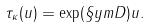Convert formula to latex. <formula><loc_0><loc_0><loc_500><loc_500>\tau _ { \kappa } ( u ) = \exp ( \S y m D ) u .</formula> 